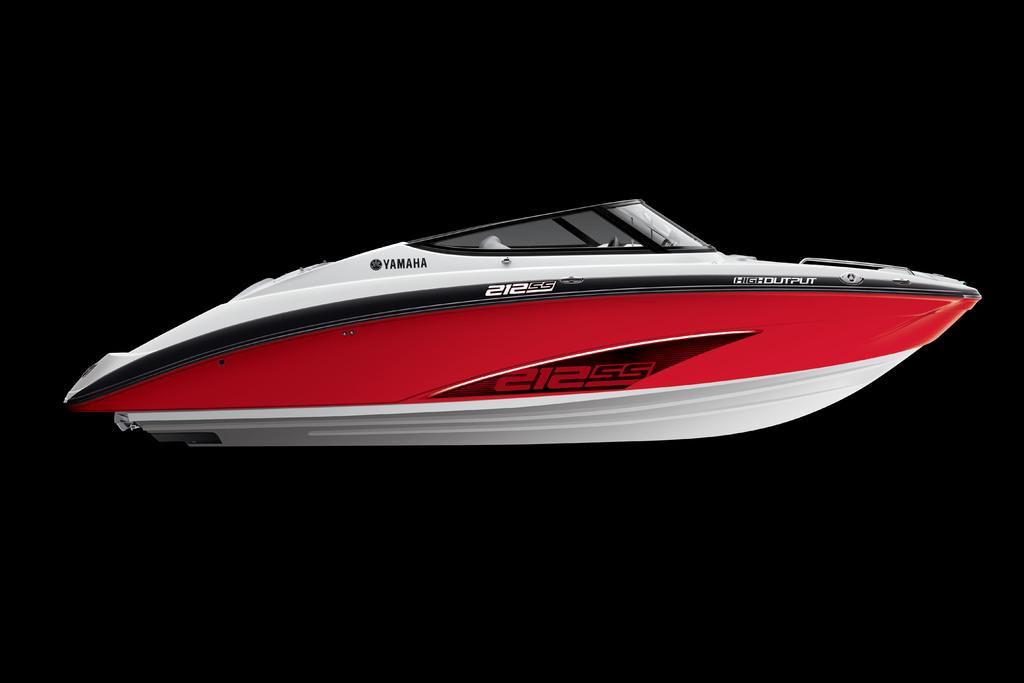What is the main subject of the image? The main subject of the image is a boat. Can you describe the background of the image? The background of the image is dark. What type of guide is leading the band in the image? There is no band or guide present in the image; it only features a boat. 